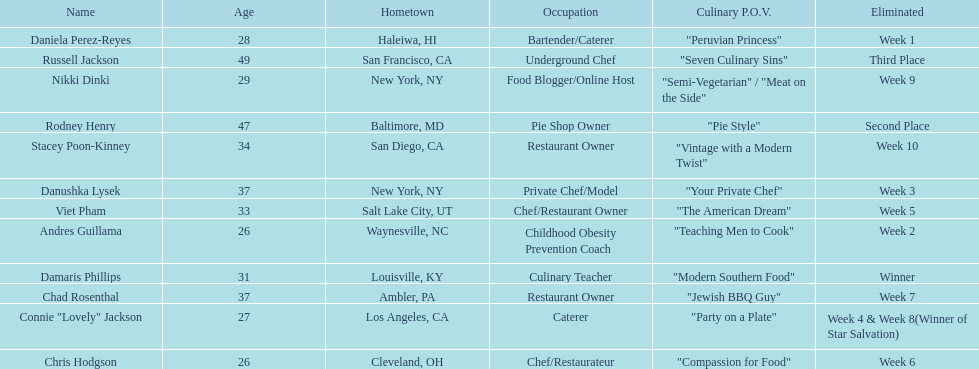Which contestant's culinary point of view had a longer description than "vintage with a modern twist"? Nikki Dinki. 